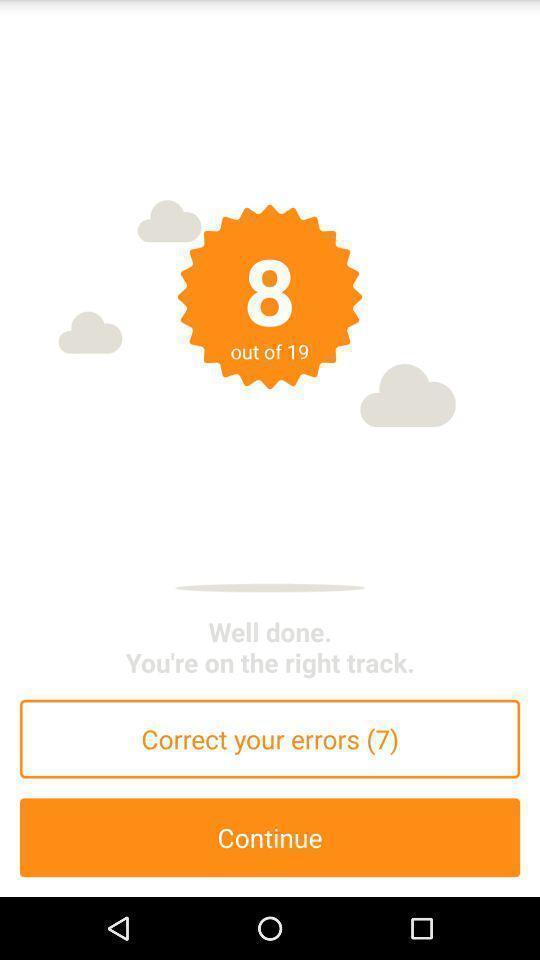Explain what's happening in this screen capture. Screen showing the number count. 